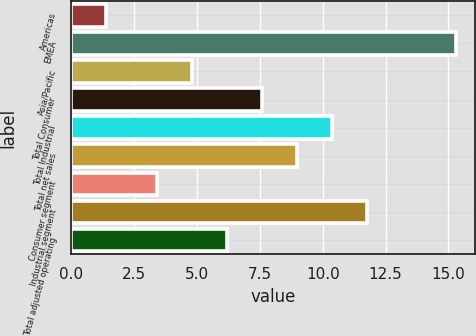<chart> <loc_0><loc_0><loc_500><loc_500><bar_chart><fcel>Americas<fcel>EMEA<fcel>Asia/Pacific<fcel>Total Consumer<fcel>Total Industrial<fcel>Total net sales<fcel>Consumer segment<fcel>Industrial segment<fcel>Total adjusted operating<nl><fcel>1.4<fcel>15.3<fcel>4.79<fcel>7.57<fcel>10.35<fcel>8.96<fcel>3.4<fcel>11.74<fcel>6.18<nl></chart> 